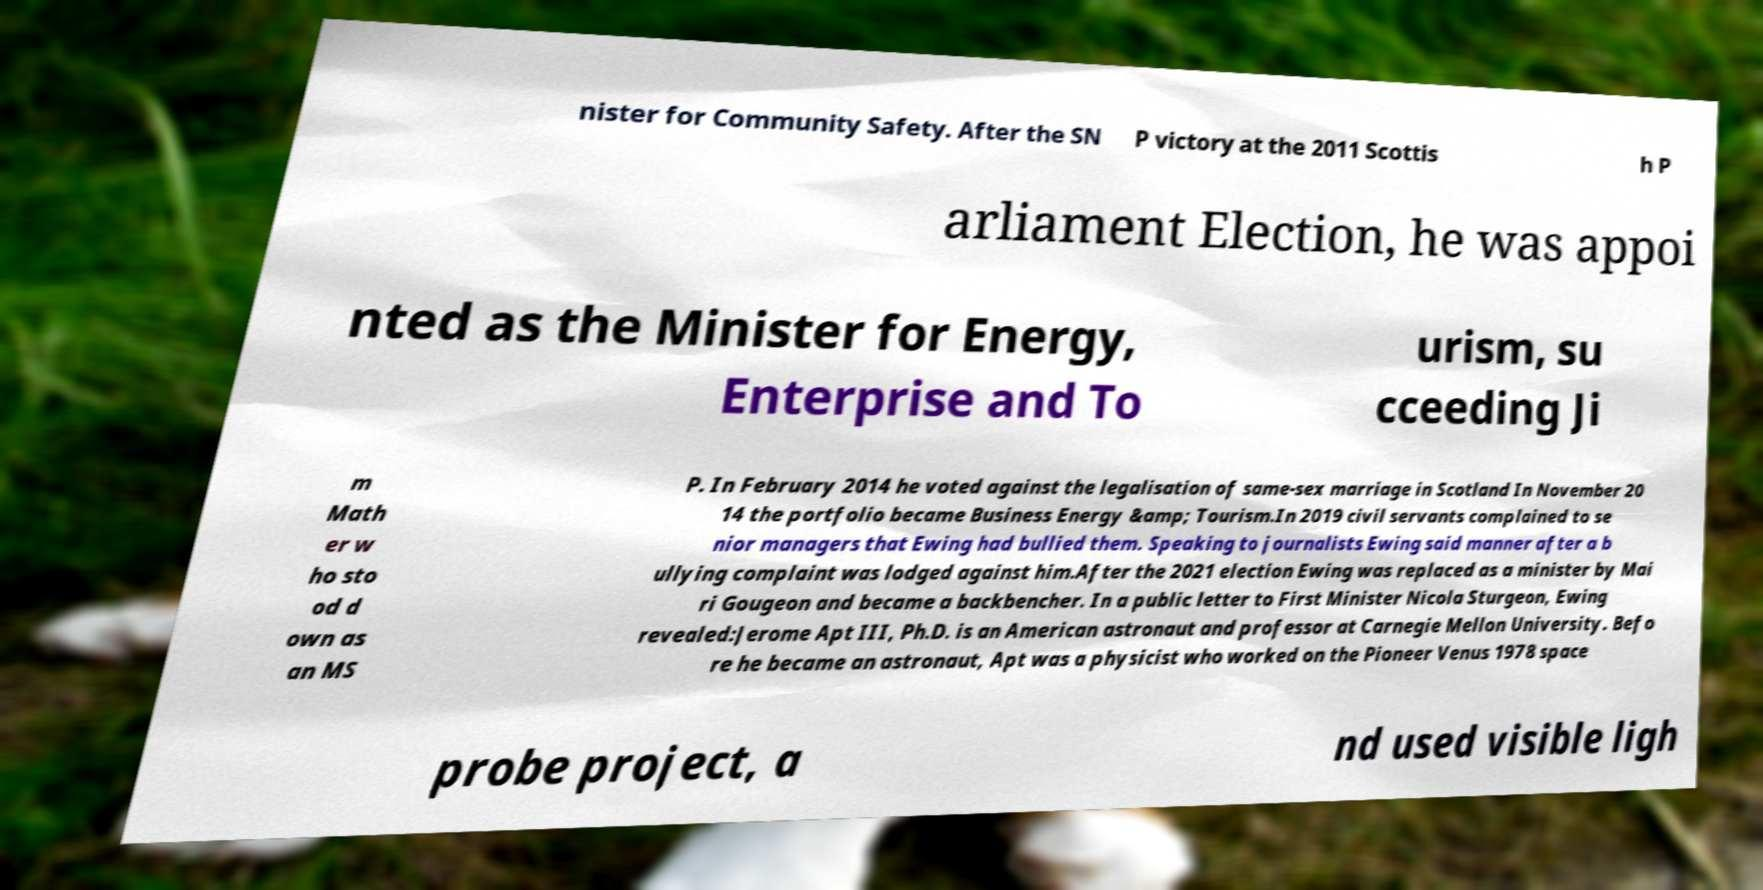Please read and relay the text visible in this image. What does it say? nister for Community Safety. After the SN P victory at the 2011 Scottis h P arliament Election, he was appoi nted as the Minister for Energy, Enterprise and To urism, su cceeding Ji m Math er w ho sto od d own as an MS P. In February 2014 he voted against the legalisation of same-sex marriage in Scotland In November 20 14 the portfolio became Business Energy &amp; Tourism.In 2019 civil servants complained to se nior managers that Ewing had bullied them. Speaking to journalists Ewing said manner after a b ullying complaint was lodged against him.After the 2021 election Ewing was replaced as a minister by Mai ri Gougeon and became a backbencher. In a public letter to First Minister Nicola Sturgeon, Ewing revealed:Jerome Apt III, Ph.D. is an American astronaut and professor at Carnegie Mellon University. Befo re he became an astronaut, Apt was a physicist who worked on the Pioneer Venus 1978 space probe project, a nd used visible ligh 